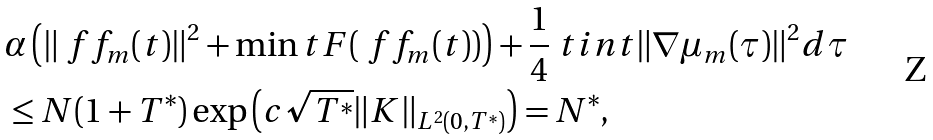Convert formula to latex. <formula><loc_0><loc_0><loc_500><loc_500>& \alpha \left ( \| \ f f _ { m } ( t ) \| ^ { 2 } + \min t F ( \ f f _ { m } ( t ) ) \right ) + \frac { 1 } { 4 } \ t i n t \| \nabla \mu _ { m } ( \tau ) \| ^ { 2 } d \tau \\ & \leq N ( 1 + T ^ { * } ) \exp { \left ( c \sqrt { T ^ { * } } \| K \| _ { L ^ { 2 } ( 0 , T ^ { * } ) } \right ) } = N ^ { * } ,</formula> 